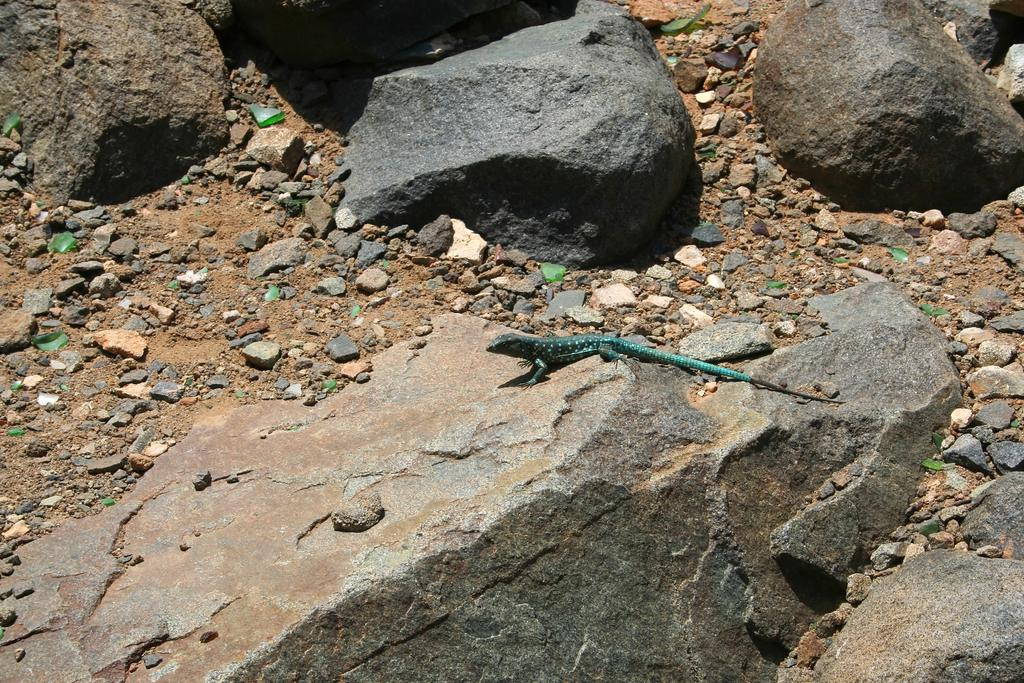What type of animal is in the image? There is a lizard in the image. What is the lizard standing on? The lizard is standing on a stone. What other elements can be seen in the image? There are small stones visible in the image. What type of toy is the lizard playing with in the image? There is no toy present in the image; it features a lizard standing on a stone. How does the coach interact with the lizard in the image? There is no coach present in the image; it features a lizard standing on a stone. 